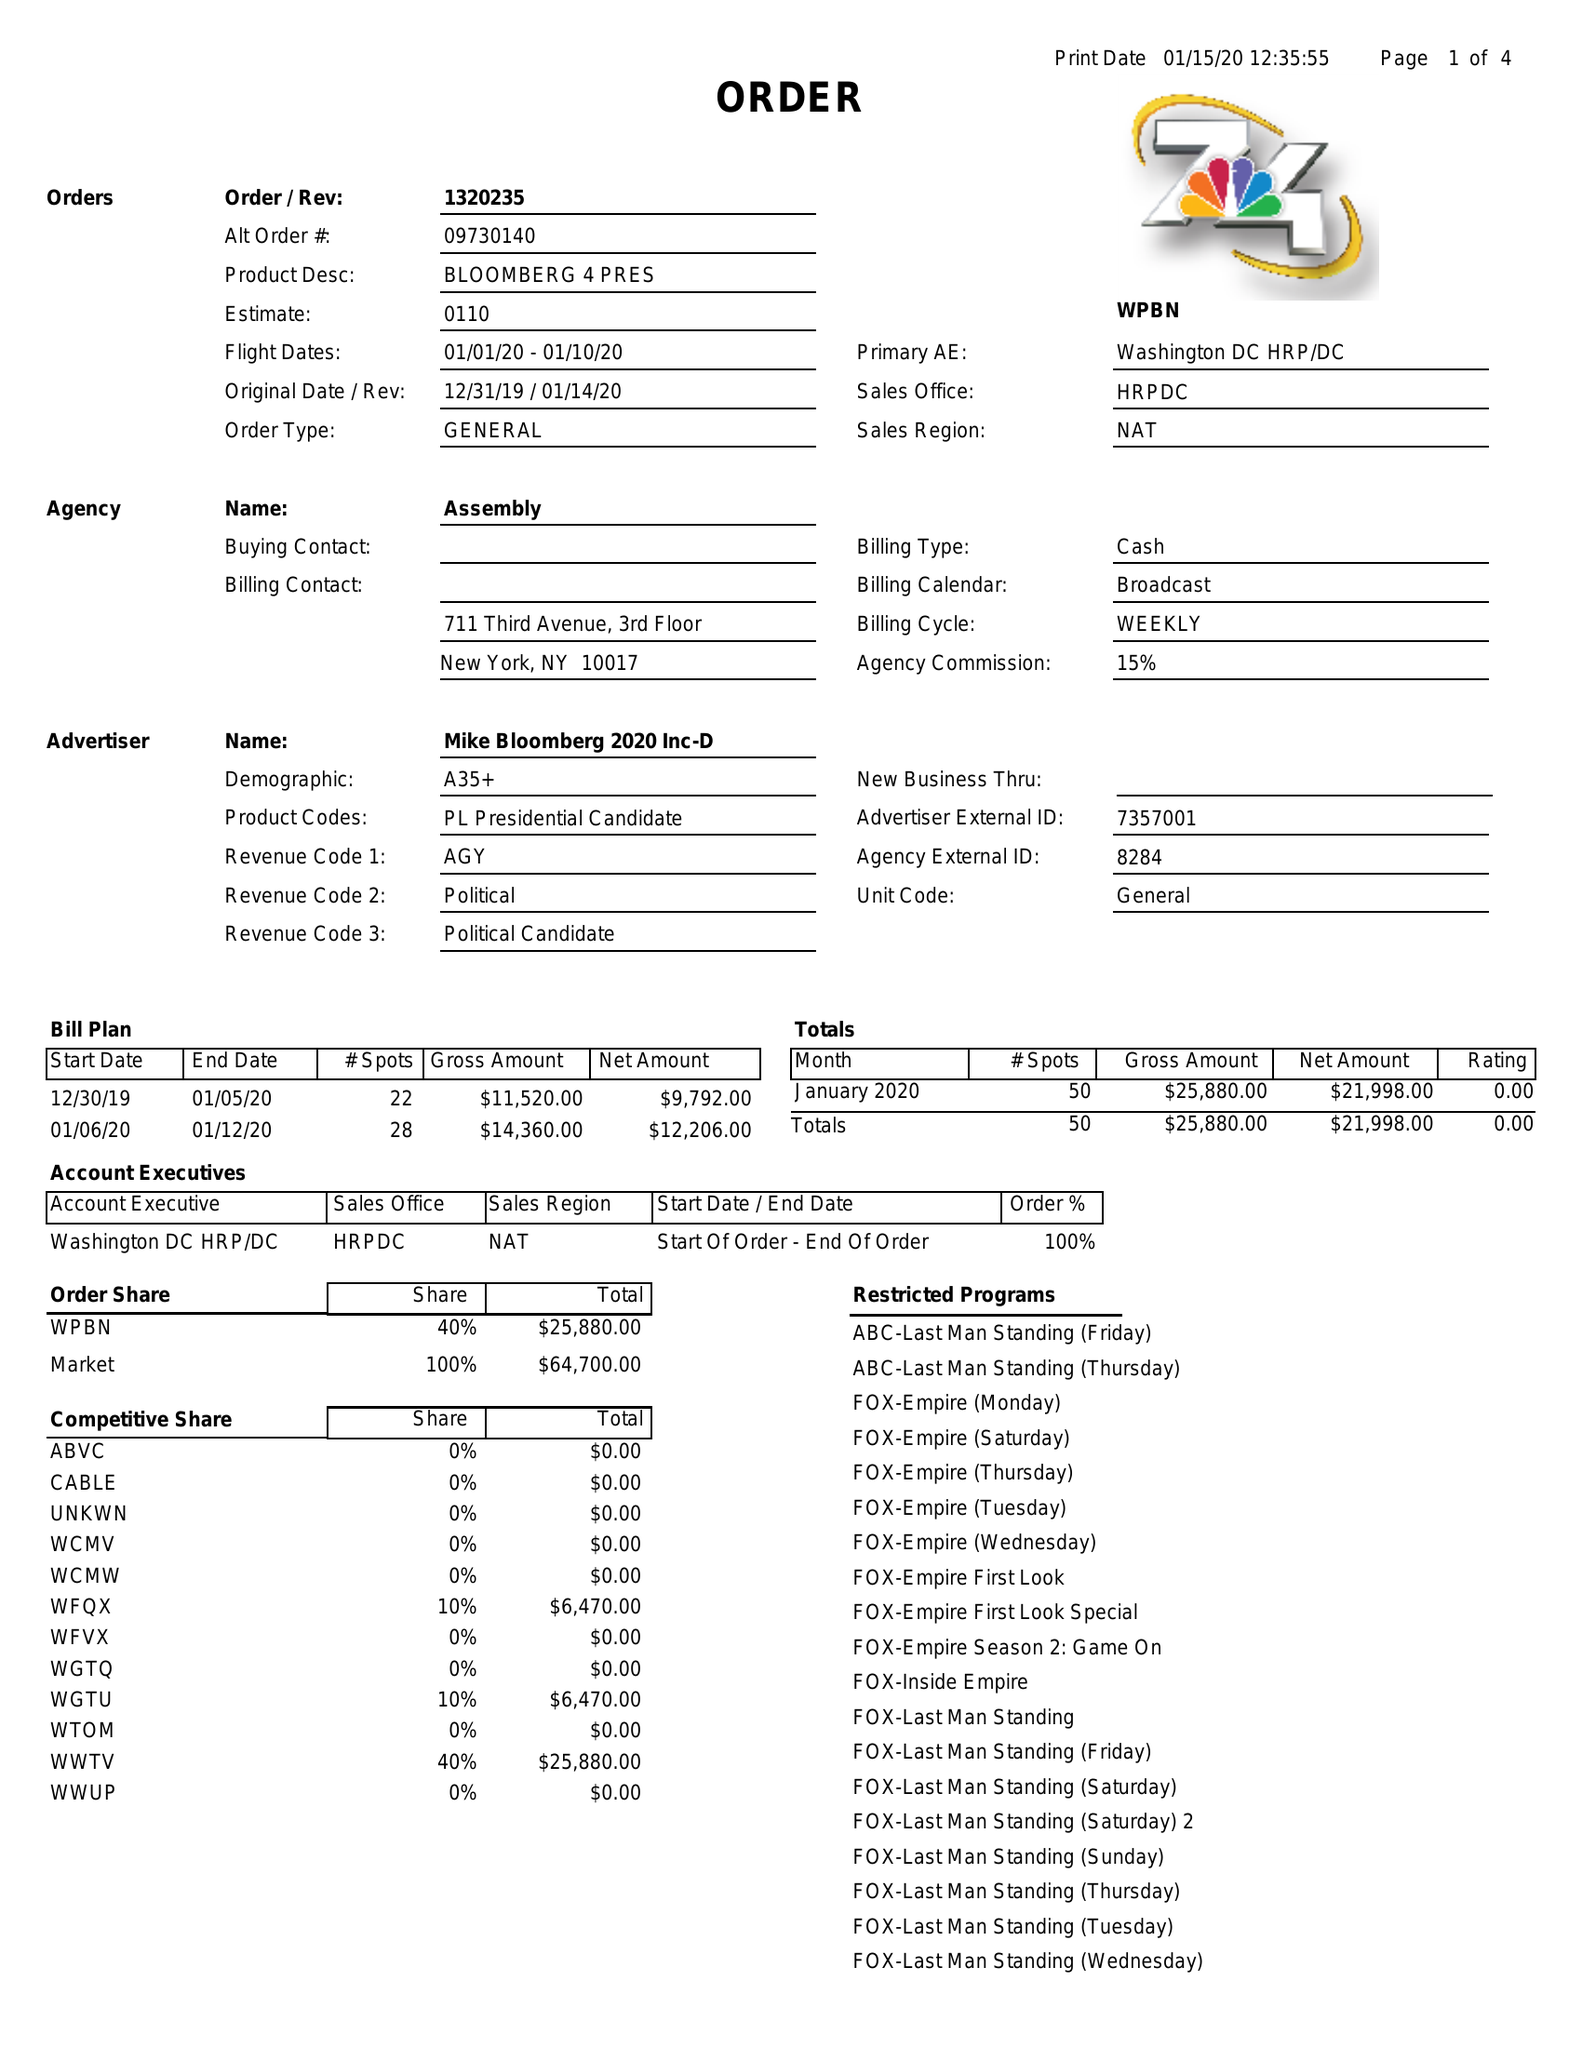What is the value for the contract_num?
Answer the question using a single word or phrase. 1320235 